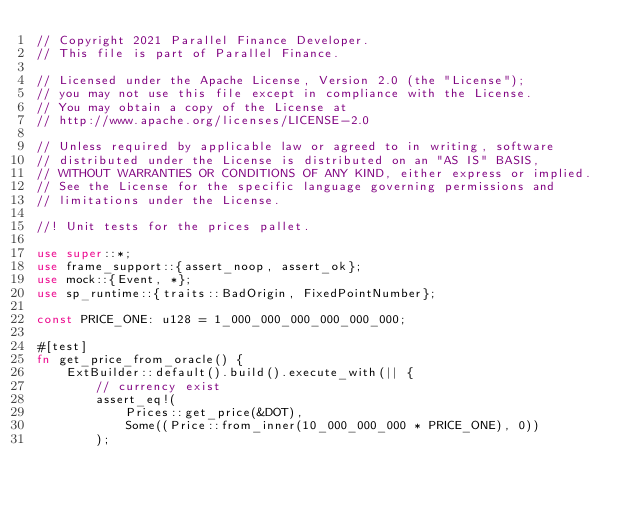Convert code to text. <code><loc_0><loc_0><loc_500><loc_500><_Rust_>// Copyright 2021 Parallel Finance Developer.
// This file is part of Parallel Finance.

// Licensed under the Apache License, Version 2.0 (the "License");
// you may not use this file except in compliance with the License.
// You may obtain a copy of the License at
// http://www.apache.org/licenses/LICENSE-2.0

// Unless required by applicable law or agreed to in writing, software
// distributed under the License is distributed on an "AS IS" BASIS,
// WITHOUT WARRANTIES OR CONDITIONS OF ANY KIND, either express or implied.
// See the License for the specific language governing permissions and
// limitations under the License.

//! Unit tests for the prices pallet.

use super::*;
use frame_support::{assert_noop, assert_ok};
use mock::{Event, *};
use sp_runtime::{traits::BadOrigin, FixedPointNumber};

const PRICE_ONE: u128 = 1_000_000_000_000_000_000;

#[test]
fn get_price_from_oracle() {
    ExtBuilder::default().build().execute_with(|| {
        // currency exist
        assert_eq!(
            Prices::get_price(&DOT),
            Some((Price::from_inner(10_000_000_000 * PRICE_ONE), 0))
        );
</code> 